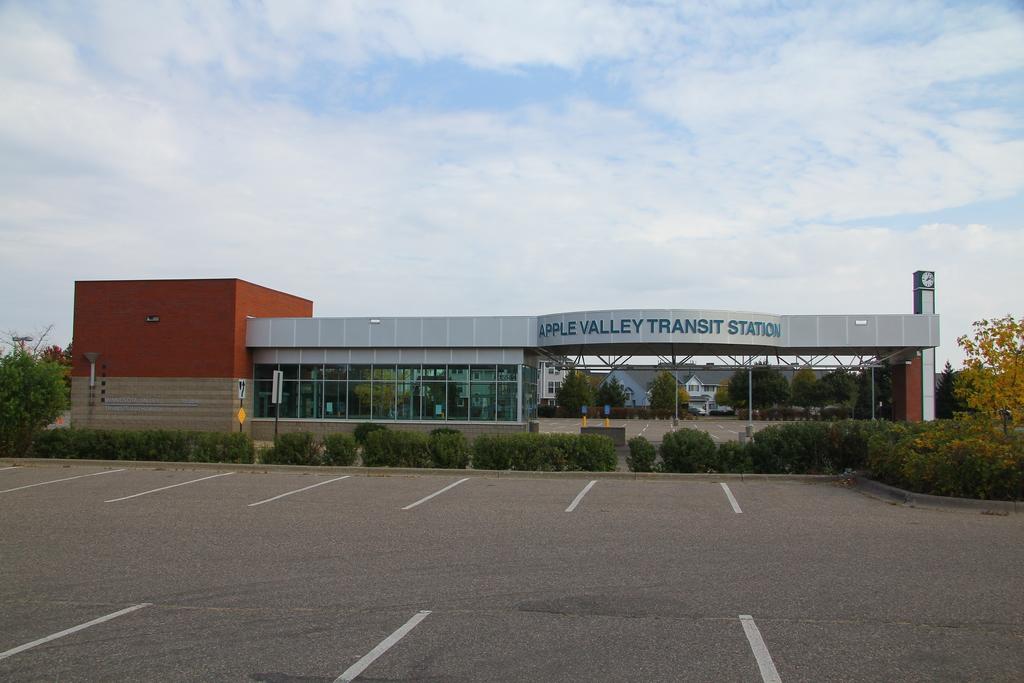What is the name of the transit station?
Give a very brief answer. Apple valley transit station. 